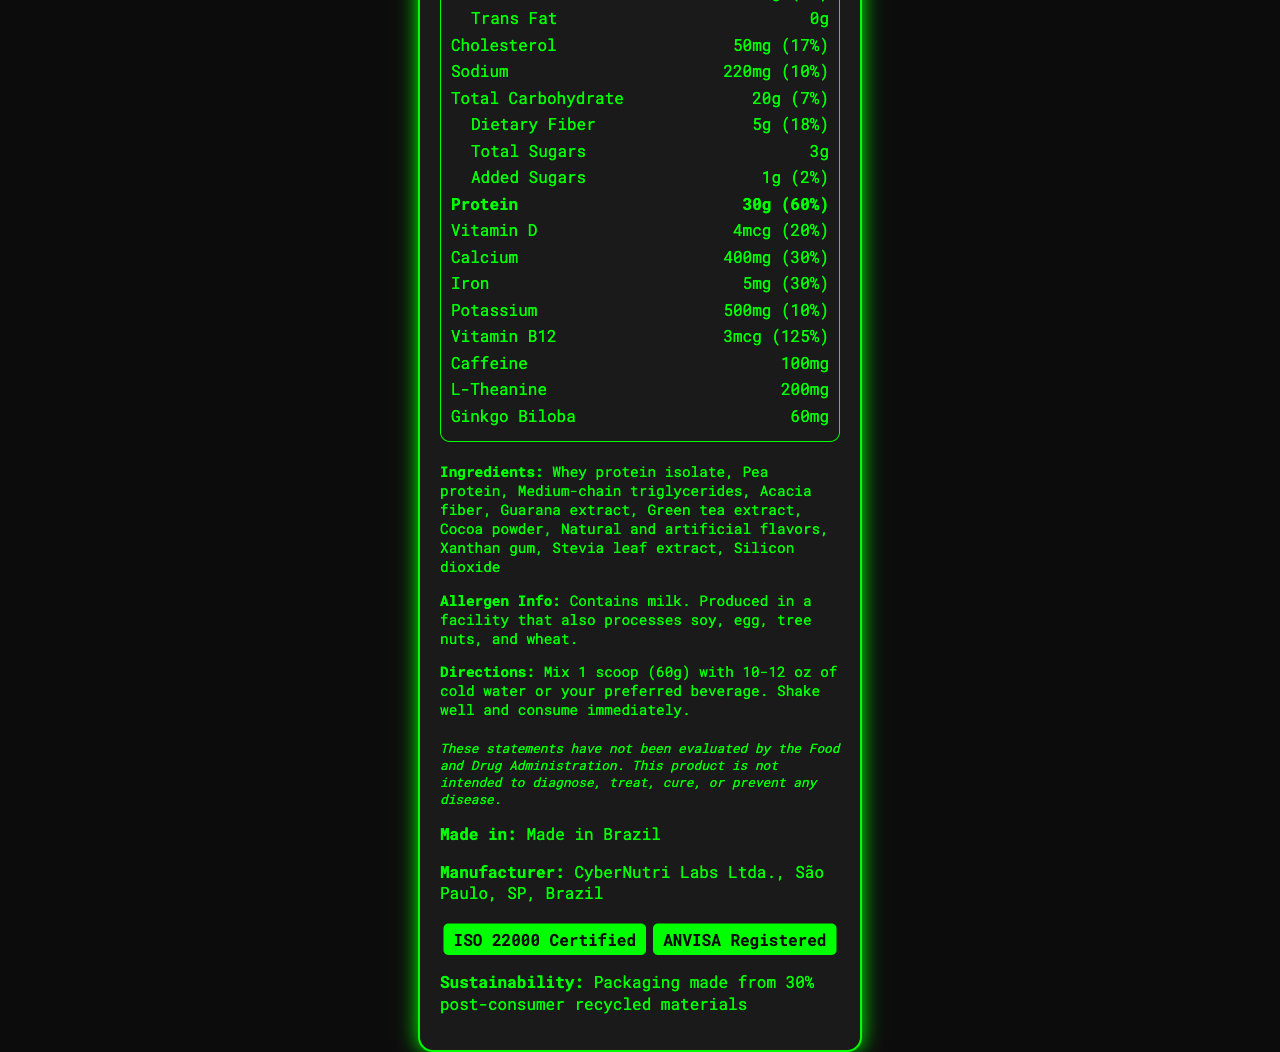what is the serving size for CyberFuel Pro? The serving size is mentioned as "1 scoop (60g)" in the Nutrition Facts.
Answer: 1 scoop (60g) how many servings are in one container of CyberFuel Pro? The document states "15 servings per container".
Answer: 15 what is the calorie count per serving of CyberFuel Pro? The calories per serving are listed as "Calories 240" on the nutrition label.
Answer: 240 how much protein is in one serving of CyberFuel Pro? The protein content per serving is indicated as "Protein 30g" with a daily value of 60%.
Answer: 30g what vitamins are included in CyberFuel Pro and in what amounts? The vitamins listed are Vitamin D with 4mcg and Vitamin B12 with 3mcg.
Answer: Vitamin D: 4mcg, Vitamin B12: 3mcg does CyberFuel Pro contain any dietary fiber? If yes, how much? The dietary fiber content is specified in the nutrition details as "Dietary Fiber 5g."
Answer: Yes, 5g which ingredients are responsible for the high caffeine content in CyberFuel Pro? The ingredients list includes "Guarana extract" and "Green tea extract," which are known for their caffeine content.
Answer: Guarana extract, Green tea extract how much calcium does one serving of CyberFuel Pro provide? A. 200mg B. 400mg C. 500mg D. 100mg The nutrition label specifies that calcium is provided at 400mg per serving.
Answer: B. 400mg which of the following certifications does CyberFuel Pro have? i. USDA Organic ii. ISO 22000 iii. ANVISA Registered iv. Gluten-Free The document mentions that CyberFuel Pro is "ISO 22000 Certified" and "ANVISA Registered."
Answer: ii and iii is CyberFuel Pro suitable for someone with a soy allergy? The allergen information states "Produced in a facility that also processes soy, egg, tree nuts, and wheat," making it potentially unsafe for someone with a soy allergy.
Answer: No summarize the nutrition and key health benefits of CyberFuel Pro in one sentence. The document highlights the high protein content, essential vitamins, amounts of dietary fiber, caffeine, and additional health-boosting ingredients like L-theanine and ginkgo biloba.
Answer: CyberFuel Pro is a high-protein meal replacement shake designed for cybersecurity professionals, providing essential vitamins and minerals, dietary fiber, and energy-boosting ingredients like caffeine and L-theanine. what is the production origin of CyberFuel Pro? The product is marked "Made in Brazil."
Answer: Made in Brazil does CyberFuel Pro contain any trans fats? The document specifically lists "Trans Fat: 0g."
Answer: No what percentage of the daily value of Vitamin B12 does one serving of CyberFuel Pro provide? The nutrition label states "Vitamin B12 3mcg (125% DV)."
Answer: 125% how should CyberFuel Pro be prepared and consumed? The instructions straightforwardly describe how to prepare and consume the shake.
Answer: Mix 1 scoop (60g) with 10-12 oz of cold water or preferred beverage, shake well, and consume immediately. can you find the amount of silicon dioxide in CyberFuel Pro? The amount of silicon dioxide is not specified in the document, only its presence in the ingredient list is mentioned.
Answer: I don't know 